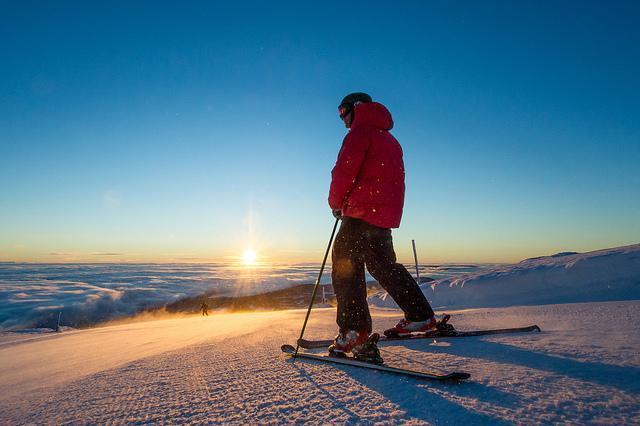How many people are watching him?
Give a very brief answer. 0. How many skiers are on the slope?
Give a very brief answer. 1. 